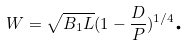Convert formula to latex. <formula><loc_0><loc_0><loc_500><loc_500>W = \sqrt { B _ { 1 } L } ( 1 - \frac { D } { P } ) ^ { 1 / 4 } \text {.}</formula> 